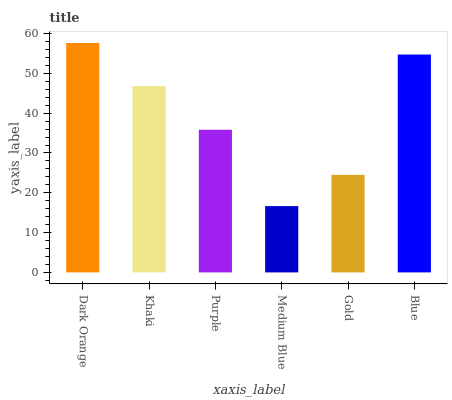Is Medium Blue the minimum?
Answer yes or no. Yes. Is Dark Orange the maximum?
Answer yes or no. Yes. Is Khaki the minimum?
Answer yes or no. No. Is Khaki the maximum?
Answer yes or no. No. Is Dark Orange greater than Khaki?
Answer yes or no. Yes. Is Khaki less than Dark Orange?
Answer yes or no. Yes. Is Khaki greater than Dark Orange?
Answer yes or no. No. Is Dark Orange less than Khaki?
Answer yes or no. No. Is Khaki the high median?
Answer yes or no. Yes. Is Purple the low median?
Answer yes or no. Yes. Is Dark Orange the high median?
Answer yes or no. No. Is Dark Orange the low median?
Answer yes or no. No. 